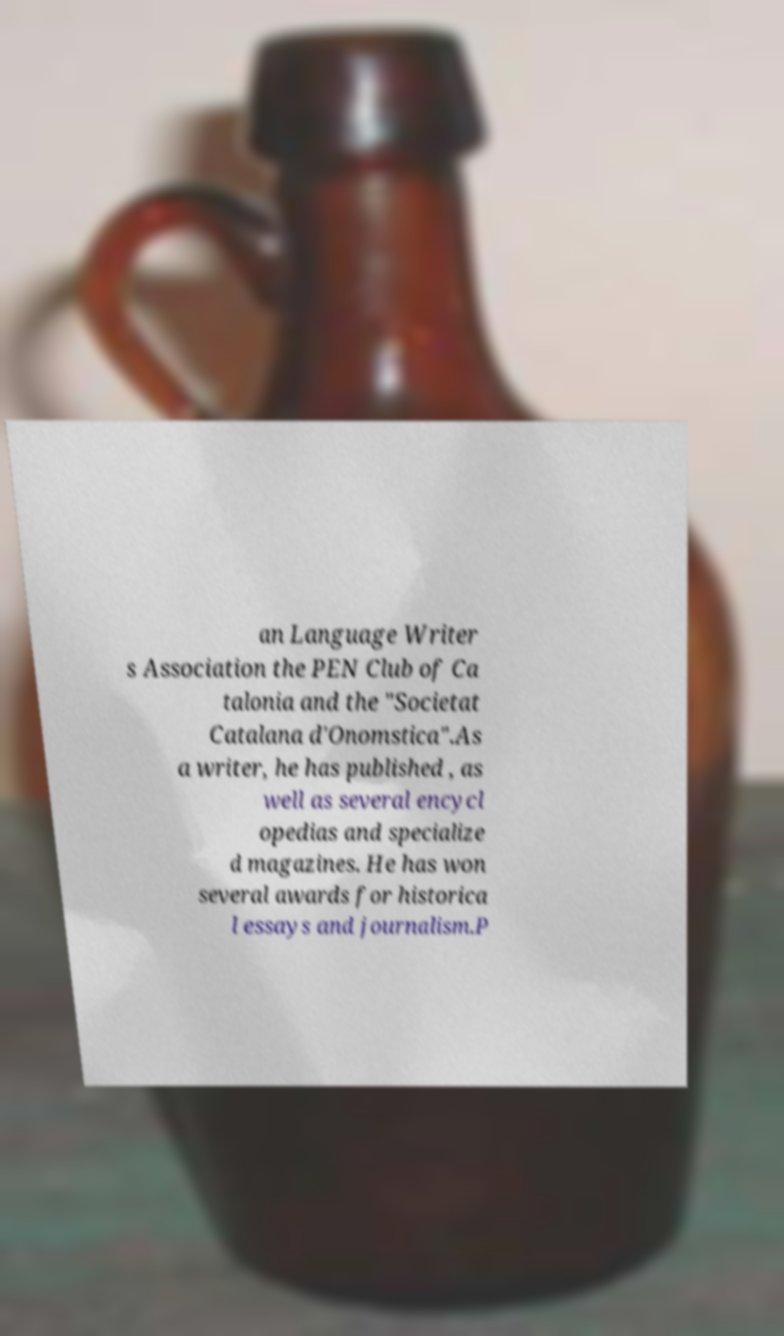Can you accurately transcribe the text from the provided image for me? an Language Writer s Association the PEN Club of Ca talonia and the "Societat Catalana d'Onomstica".As a writer, he has published , as well as several encycl opedias and specialize d magazines. He has won several awards for historica l essays and journalism.P 